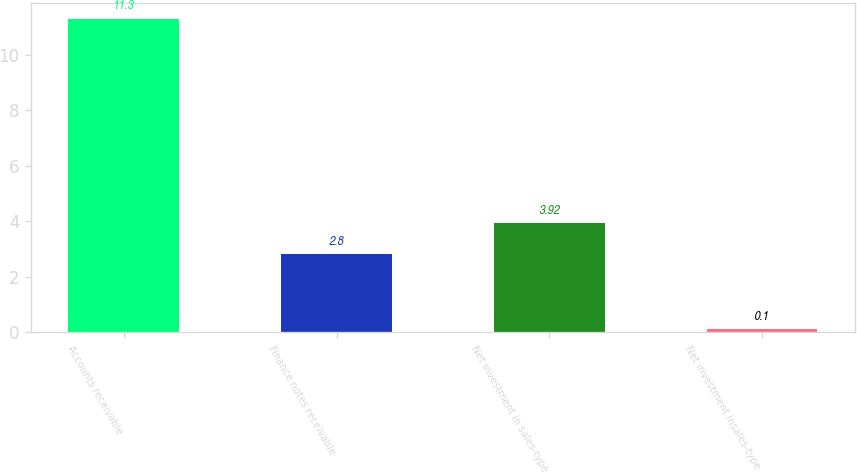Convert chart to OTSL. <chart><loc_0><loc_0><loc_500><loc_500><bar_chart><fcel>Accounts receivable<fcel>Finance notes receivable<fcel>Net investment in sales-type<fcel>Net investment insales-type<nl><fcel>11.3<fcel>2.8<fcel>3.92<fcel>0.1<nl></chart> 